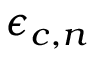<formula> <loc_0><loc_0><loc_500><loc_500>\epsilon _ { c , n }</formula> 